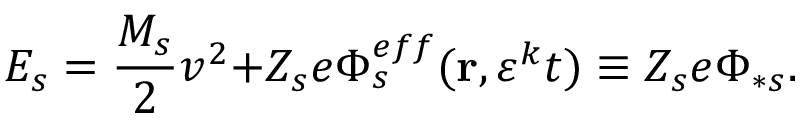Convert formula to latex. <formula><loc_0><loc_0><loc_500><loc_500>E _ { s } = \frac { M _ { s } } { 2 } v ^ { 2 } + { Z _ { s } e } \Phi _ { s } ^ { e f f } ( r , \varepsilon ^ { k } t ) \equiv Z _ { s } e \Phi _ { \ast s } .</formula> 